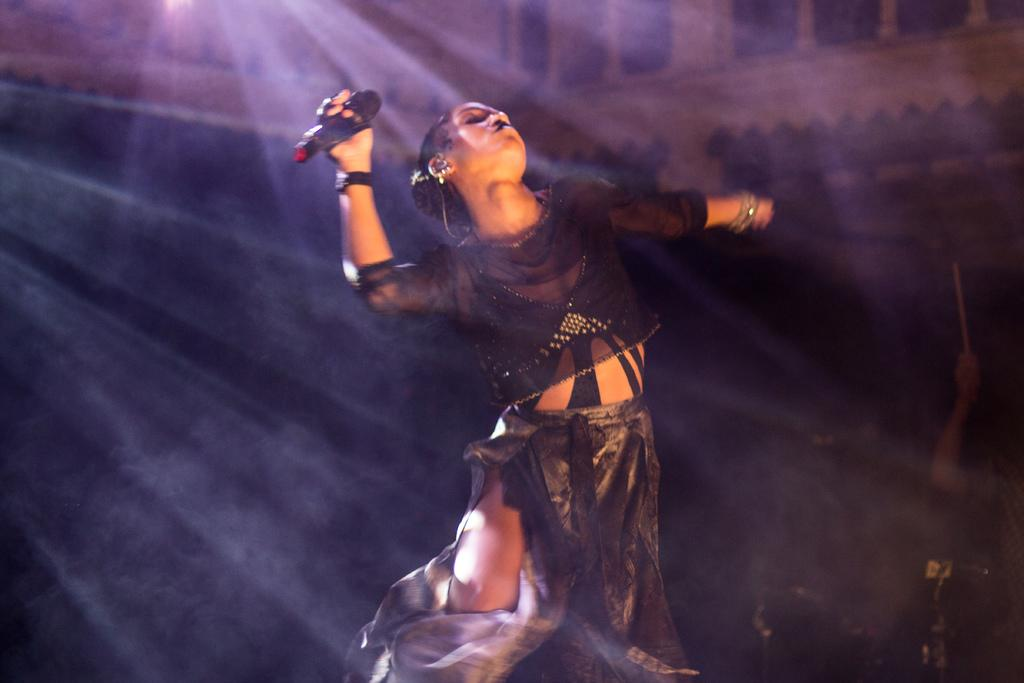What is the main subject of the image? The main subject of the image is a woman. Where is the woman located in the image? The woman is standing in a dancing poster. What is the woman holding in her hand? The woman is holding an object in her hand. Can you describe the person in the background of the image? There is a person in the background of the image, and they are holding an object in their hand. What type of island can be seen in the background of the image? There is no island visible in the background of the image. How many hands does the woman have in the image? The woman has two hands in the image, as is typical for humans. 